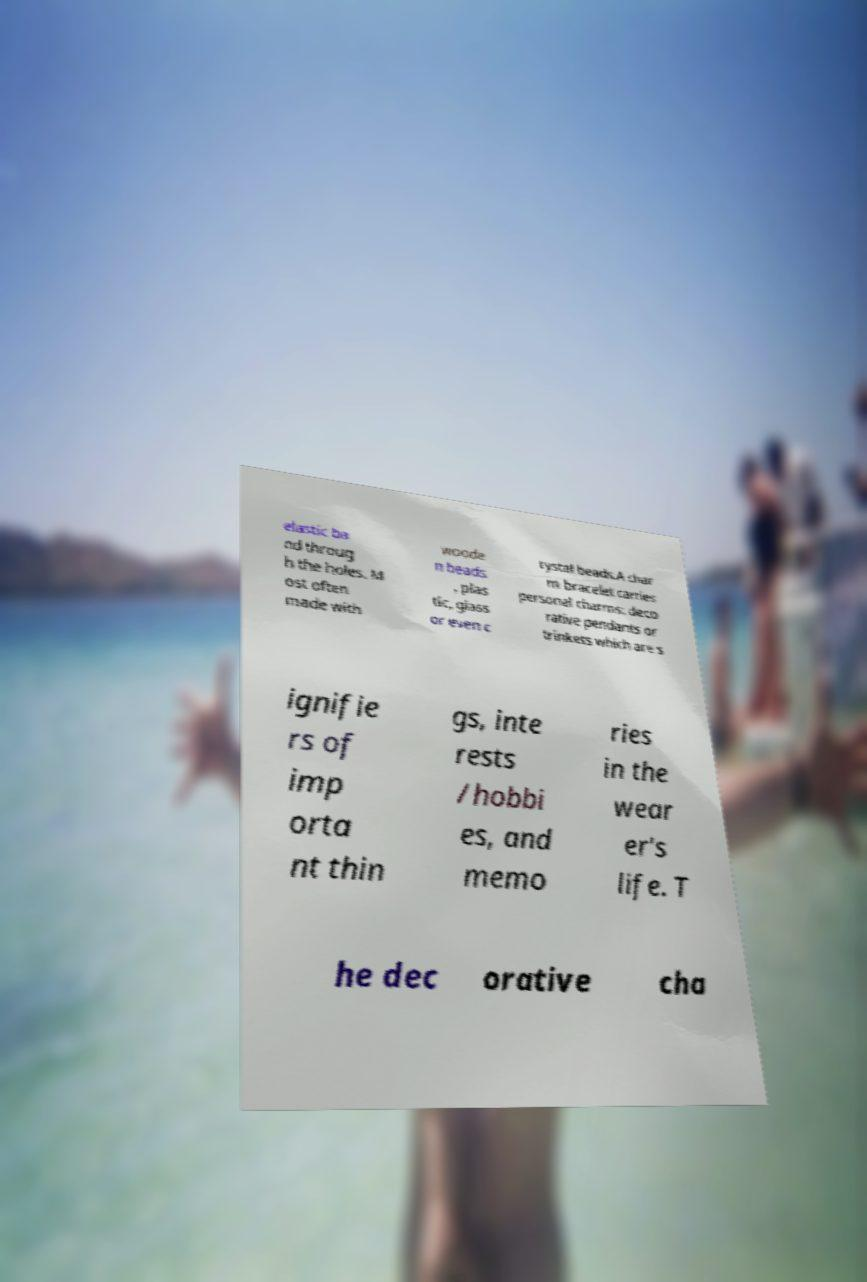Please read and relay the text visible in this image. What does it say? elastic ba nd throug h the holes. M ost often made with woode n beads , plas tic, glass or even c rystal beads.A char m bracelet carries personal charms: deco rative pendants or trinkets which are s ignifie rs of imp orta nt thin gs, inte rests /hobbi es, and memo ries in the wear er's life. T he dec orative cha 